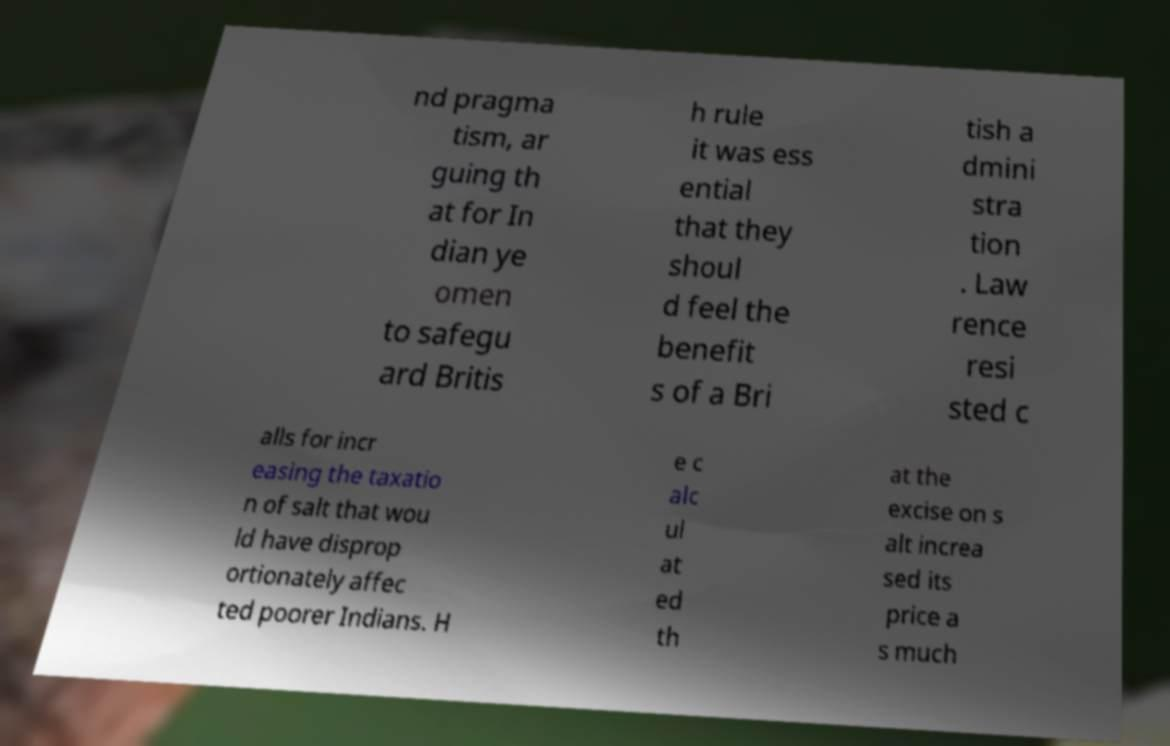Please identify and transcribe the text found in this image. nd pragma tism, ar guing th at for In dian ye omen to safegu ard Britis h rule it was ess ential that they shoul d feel the benefit s of a Bri tish a dmini stra tion . Law rence resi sted c alls for incr easing the taxatio n of salt that wou ld have disprop ortionately affec ted poorer Indians. H e c alc ul at ed th at the excise on s alt increa sed its price a s much 